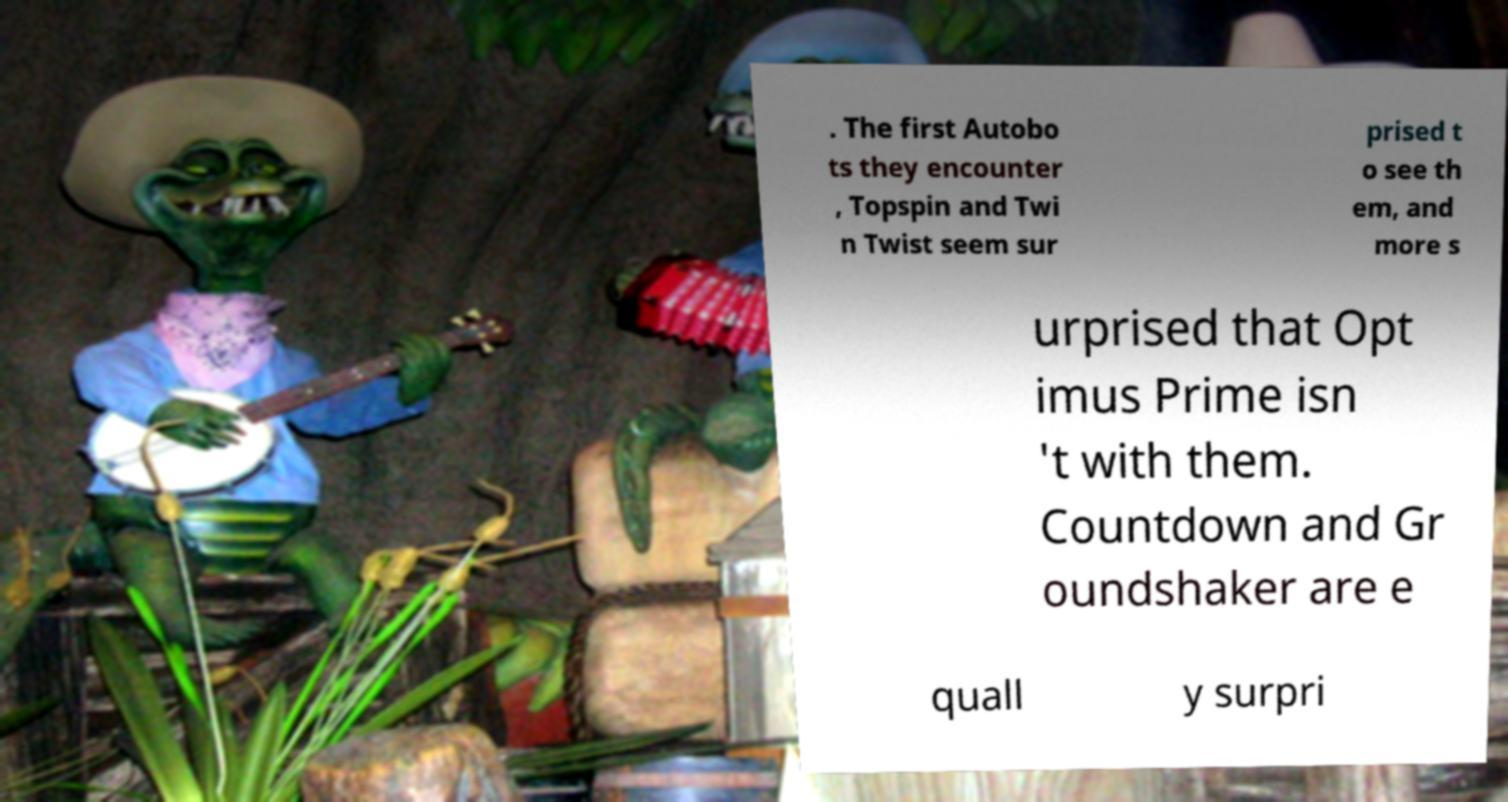Please identify and transcribe the text found in this image. . The first Autobo ts they encounter , Topspin and Twi n Twist seem sur prised t o see th em, and more s urprised that Opt imus Prime isn 't with them. Countdown and Gr oundshaker are e quall y surpri 